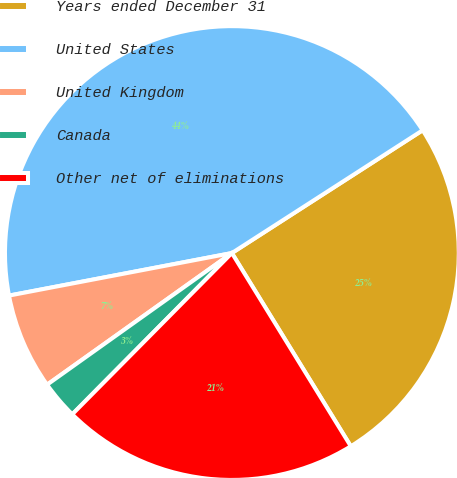Convert chart. <chart><loc_0><loc_0><loc_500><loc_500><pie_chart><fcel>Years ended December 31<fcel>United States<fcel>United Kingdom<fcel>Canada<fcel>Other net of eliminations<nl><fcel>25.32%<fcel>43.9%<fcel>6.85%<fcel>2.73%<fcel>21.2%<nl></chart> 